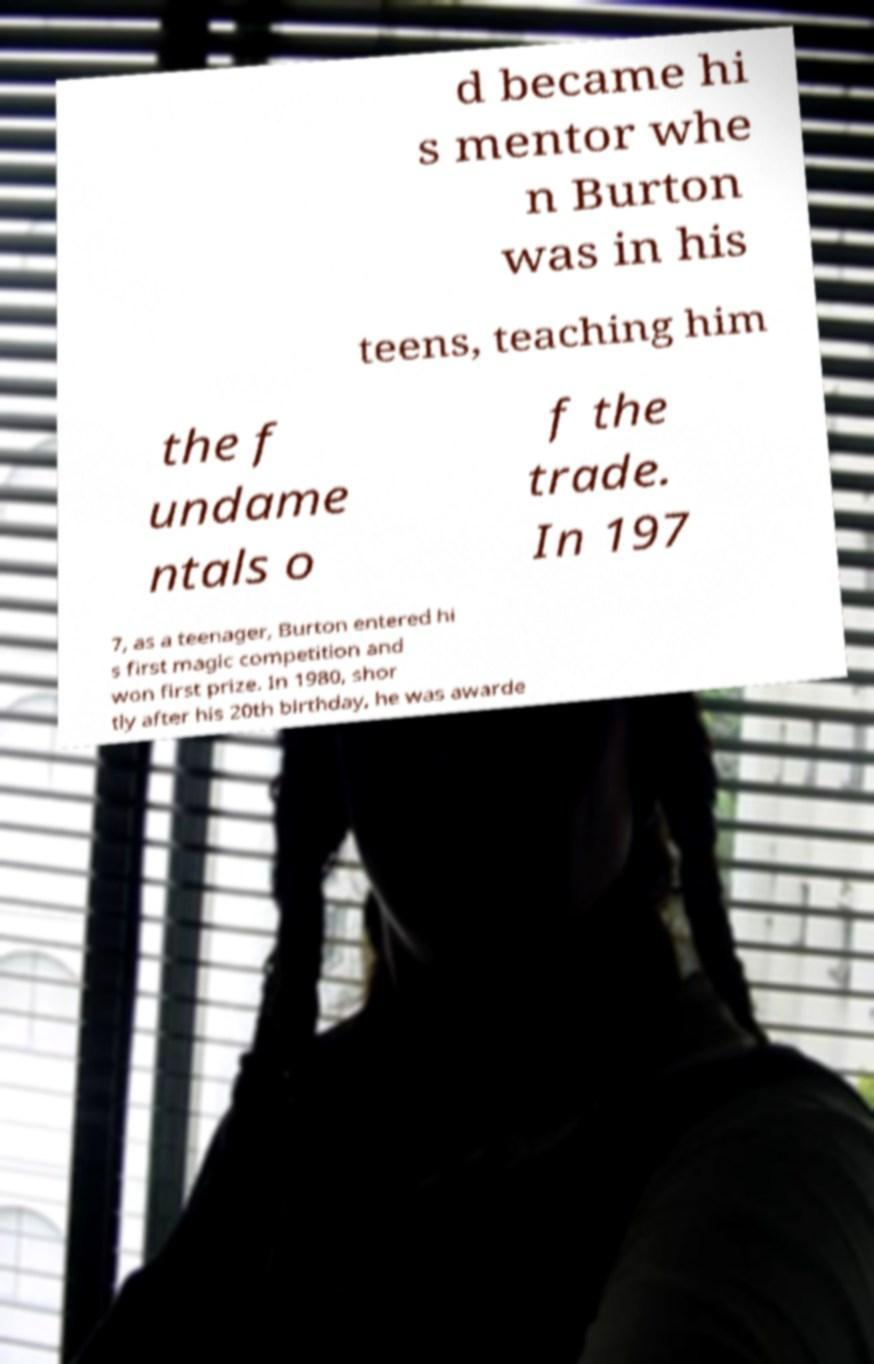Please identify and transcribe the text found in this image. d became hi s mentor whe n Burton was in his teens, teaching him the f undame ntals o f the trade. In 197 7, as a teenager, Burton entered hi s first magic competition and won first prize. In 1980, shor tly after his 20th birthday, he was awarde 